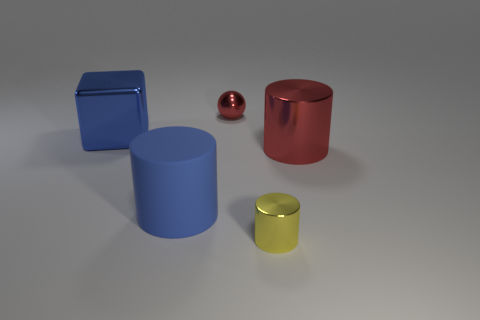Are there any other things that are made of the same material as the large blue cylinder?
Offer a terse response. No. Are there more things that are to the left of the large red metallic object than tiny blue cylinders?
Make the answer very short. Yes. Are there any big red shiny things of the same shape as the big matte thing?
Your response must be concise. Yes. Is the material of the blue cylinder the same as the cylinder on the right side of the tiny yellow metal cylinder?
Give a very brief answer. No. What is the color of the big shiny cylinder?
Give a very brief answer. Red. What number of yellow cylinders are behind the large cylinder that is in front of the large cylinder that is on the right side of the ball?
Provide a succinct answer. 0. There is a big blue cylinder; are there any small metallic spheres in front of it?
Provide a succinct answer. No. How many small red things have the same material as the large blue cube?
Your response must be concise. 1. How many objects are blue metallic things or small red metallic balls?
Provide a short and direct response. 2. Is there a purple sphere?
Your response must be concise. No. 